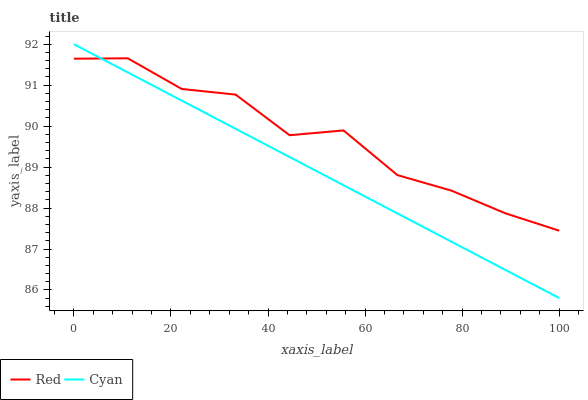Does Cyan have the minimum area under the curve?
Answer yes or no. Yes. Does Red have the maximum area under the curve?
Answer yes or no. Yes. Does Red have the minimum area under the curve?
Answer yes or no. No. Is Cyan the smoothest?
Answer yes or no. Yes. Is Red the roughest?
Answer yes or no. Yes. Is Red the smoothest?
Answer yes or no. No. Does Red have the lowest value?
Answer yes or no. No. Does Cyan have the highest value?
Answer yes or no. Yes. Does Red have the highest value?
Answer yes or no. No. Does Red intersect Cyan?
Answer yes or no. Yes. Is Red less than Cyan?
Answer yes or no. No. Is Red greater than Cyan?
Answer yes or no. No. 